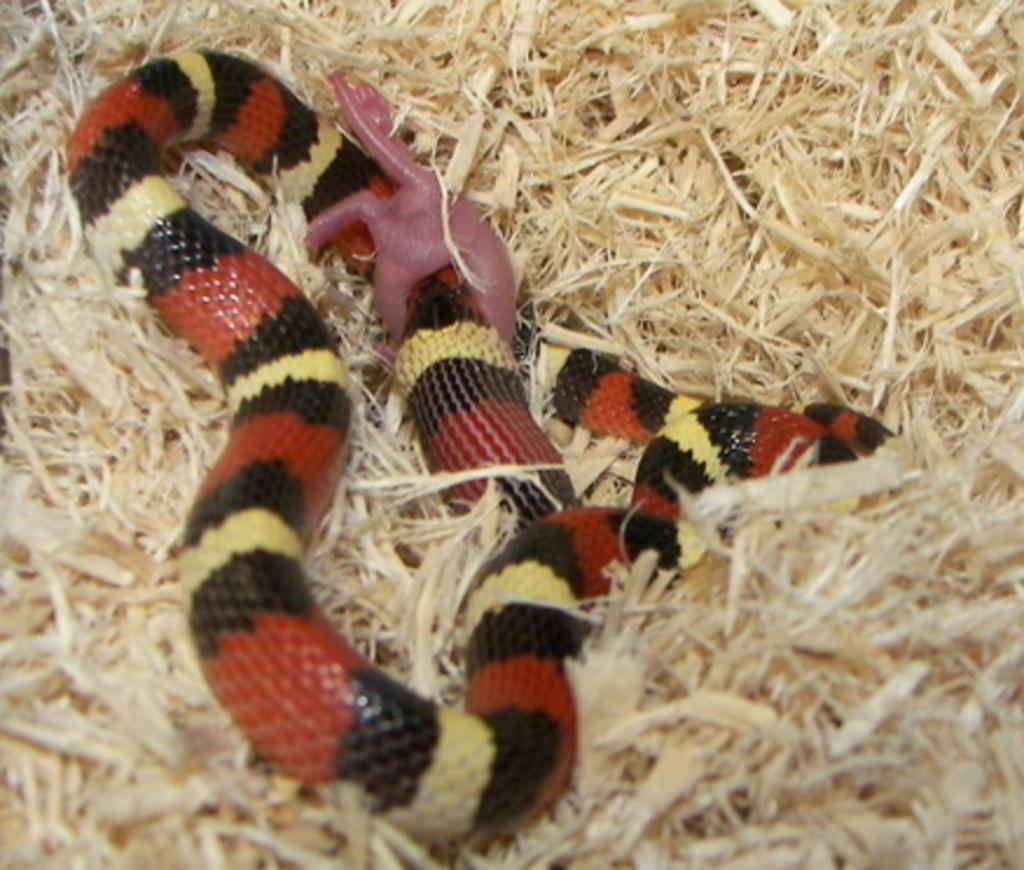What type of animal is in the image? There is a snake in the image. What colors can be seen on the snake? The snake has red and black colors. What is the snake's environment in the image? The snake is on dry grass in the image. What level of reasoning does the snake exhibit in the image? The image does not show the snake exhibiting any reasoning, as it is a photograph and not a depiction of the snake's thought process. 